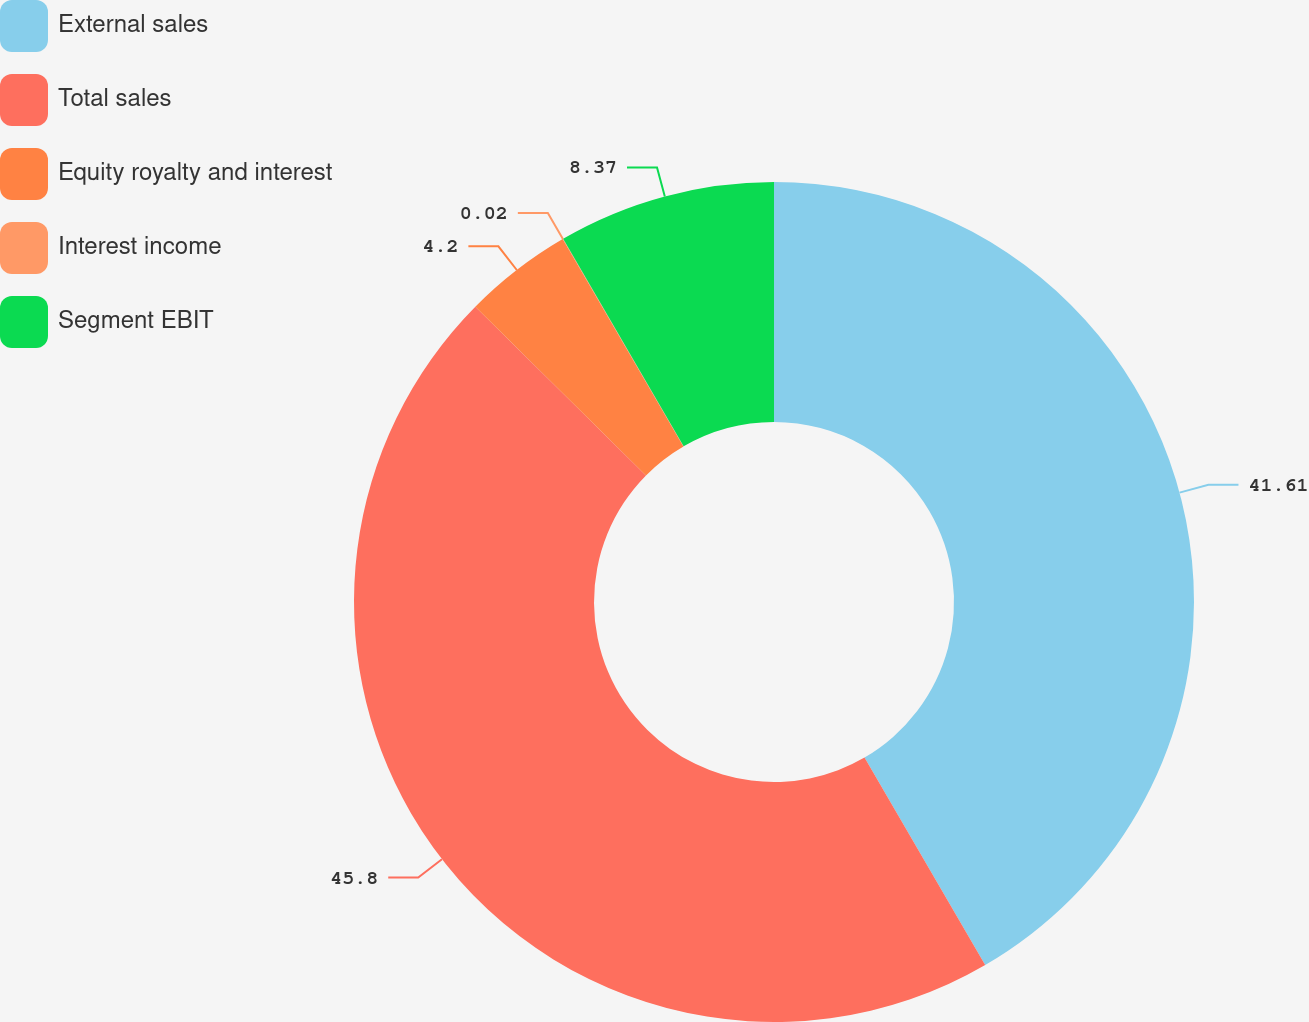<chart> <loc_0><loc_0><loc_500><loc_500><pie_chart><fcel>External sales<fcel>Total sales<fcel>Equity royalty and interest<fcel>Interest income<fcel>Segment EBIT<nl><fcel>41.61%<fcel>45.79%<fcel>4.2%<fcel>0.02%<fcel>8.37%<nl></chart> 